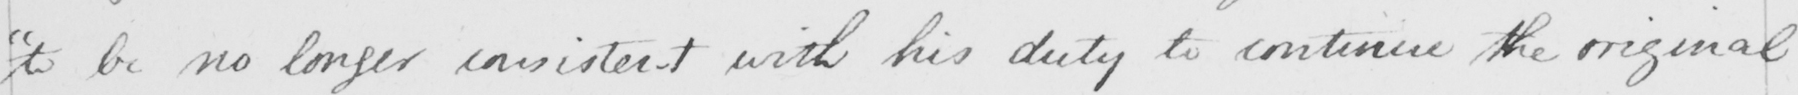Can you read and transcribe this handwriting? " to be no longer consistent with his duty to continue the original 